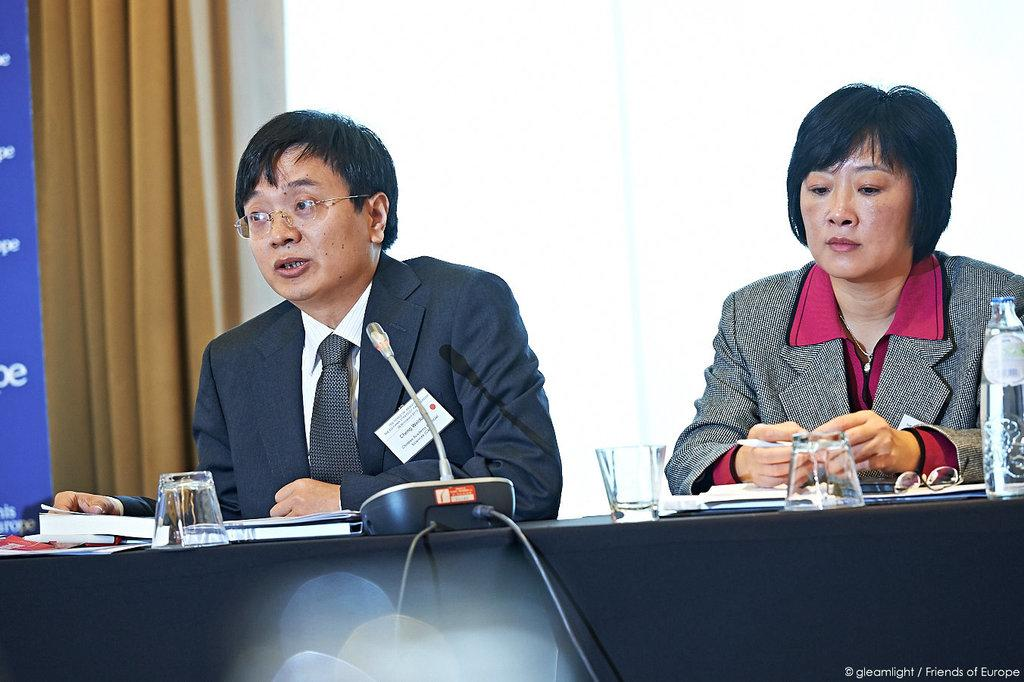How many people are in the image? There are two people in the image, a man and a woman. What are the man and woman doing in the image? Both the man and woman are sitting on chairs. Where are the chairs located in relation to the table? The chairs are near a table. What items can be seen on the table in the image? There are glasses, spectacles, bottles, books, and a mic on the table. What type of fish can be seen swimming in the glasses on the table? There are no fish present in the image; the glasses on the table contain liquid, not fish. 